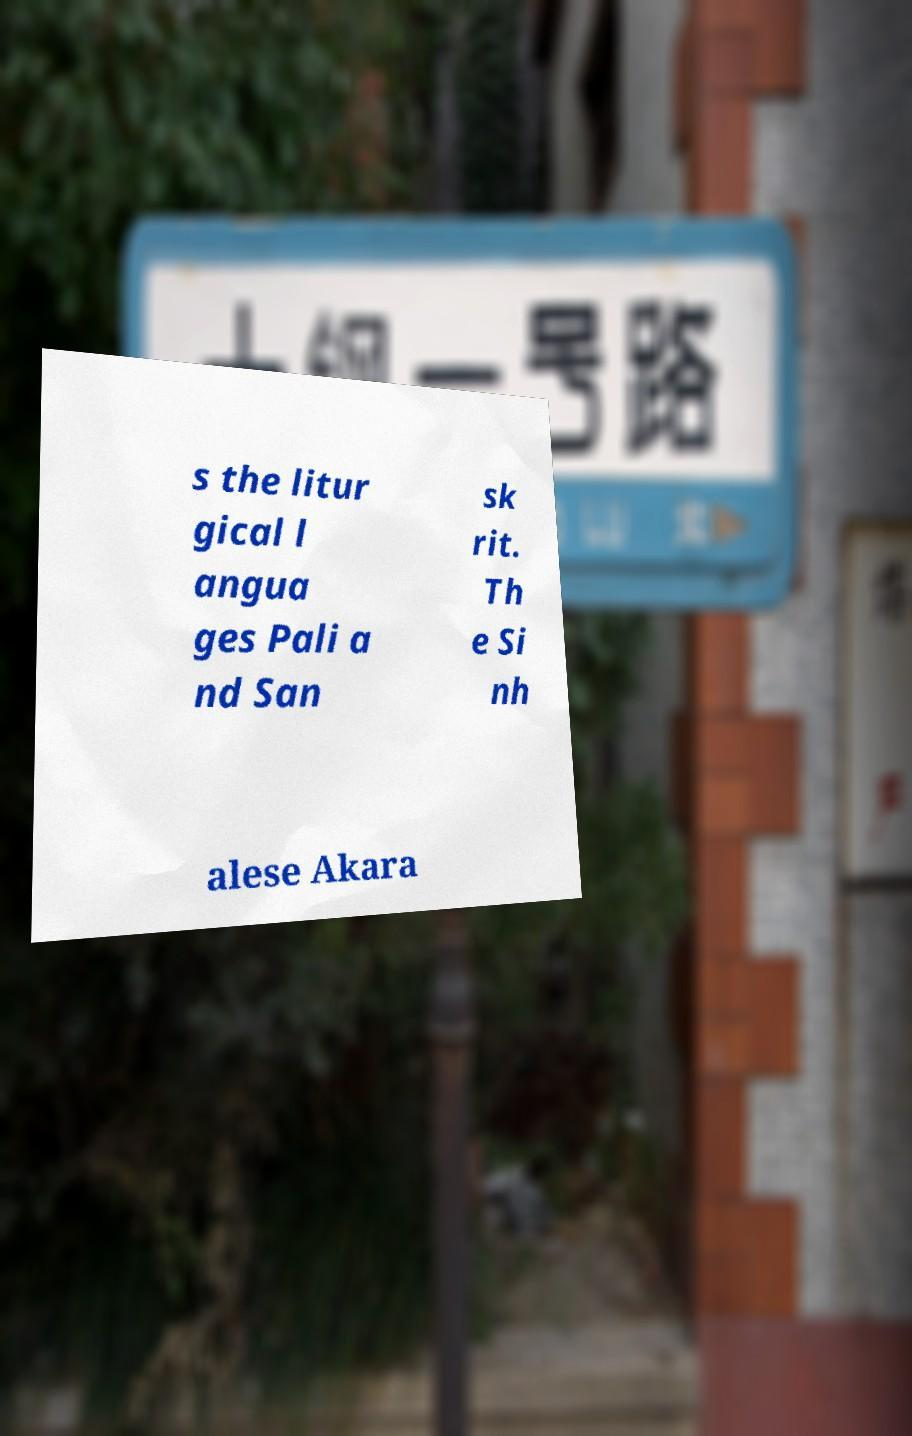I need the written content from this picture converted into text. Can you do that? s the litur gical l angua ges Pali a nd San sk rit. Th e Si nh alese Akara 